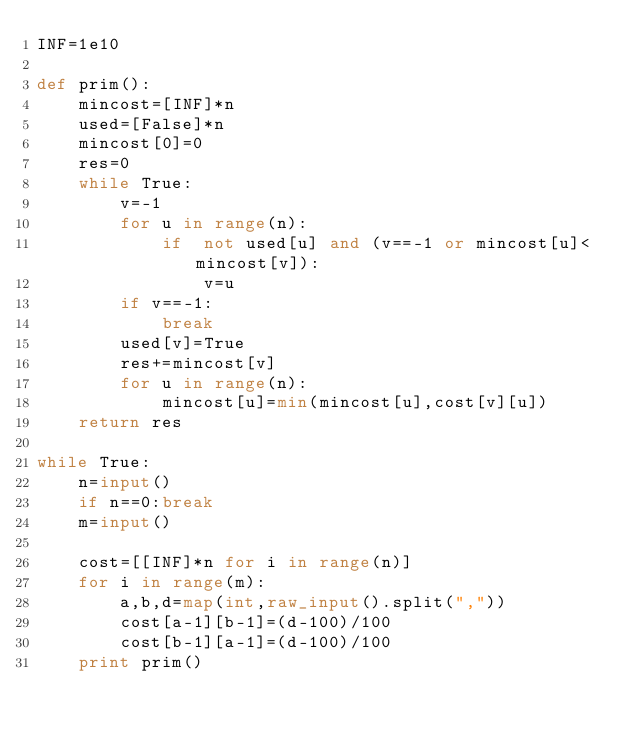<code> <loc_0><loc_0><loc_500><loc_500><_Python_>INF=1e10

def prim():
    mincost=[INF]*n
    used=[False]*n
    mincost[0]=0
    res=0
    while True:
        v=-1
        for u in range(n):
            if  not used[u] and (v==-1 or mincost[u]<mincost[v]):
                v=u
        if v==-1:
            break
        used[v]=True
        res+=mincost[v]
        for u in range(n):
            mincost[u]=min(mincost[u],cost[v][u])
    return res

while True:
    n=input()
    if n==0:break
    m=input()

    cost=[[INF]*n for i in range(n)]
    for i in range(m):
        a,b,d=map(int,raw_input().split(","))
        cost[a-1][b-1]=(d-100)/100
        cost[b-1][a-1]=(d-100)/100
    print prim()</code> 